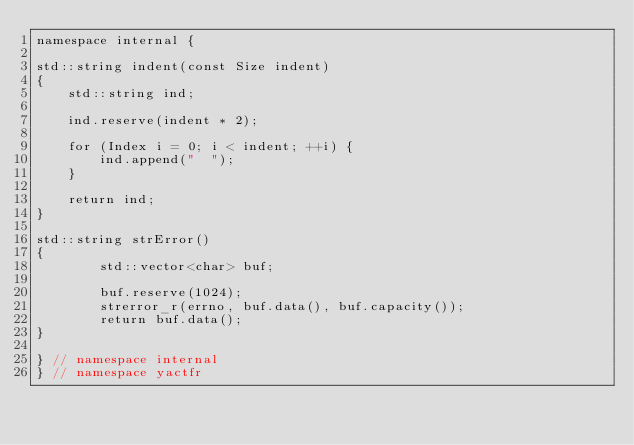<code> <loc_0><loc_0><loc_500><loc_500><_C++_>namespace internal {

std::string indent(const Size indent)
{
    std::string ind;

    ind.reserve(indent * 2);

    for (Index i = 0; i < indent; ++i) {
        ind.append("  ");
    }

    return ind;
}

std::string strError()
{
        std::vector<char> buf;

        buf.reserve(1024);
        strerror_r(errno, buf.data(), buf.capacity());
        return buf.data();
}

} // namespace internal
} // namespace yactfr
</code> 